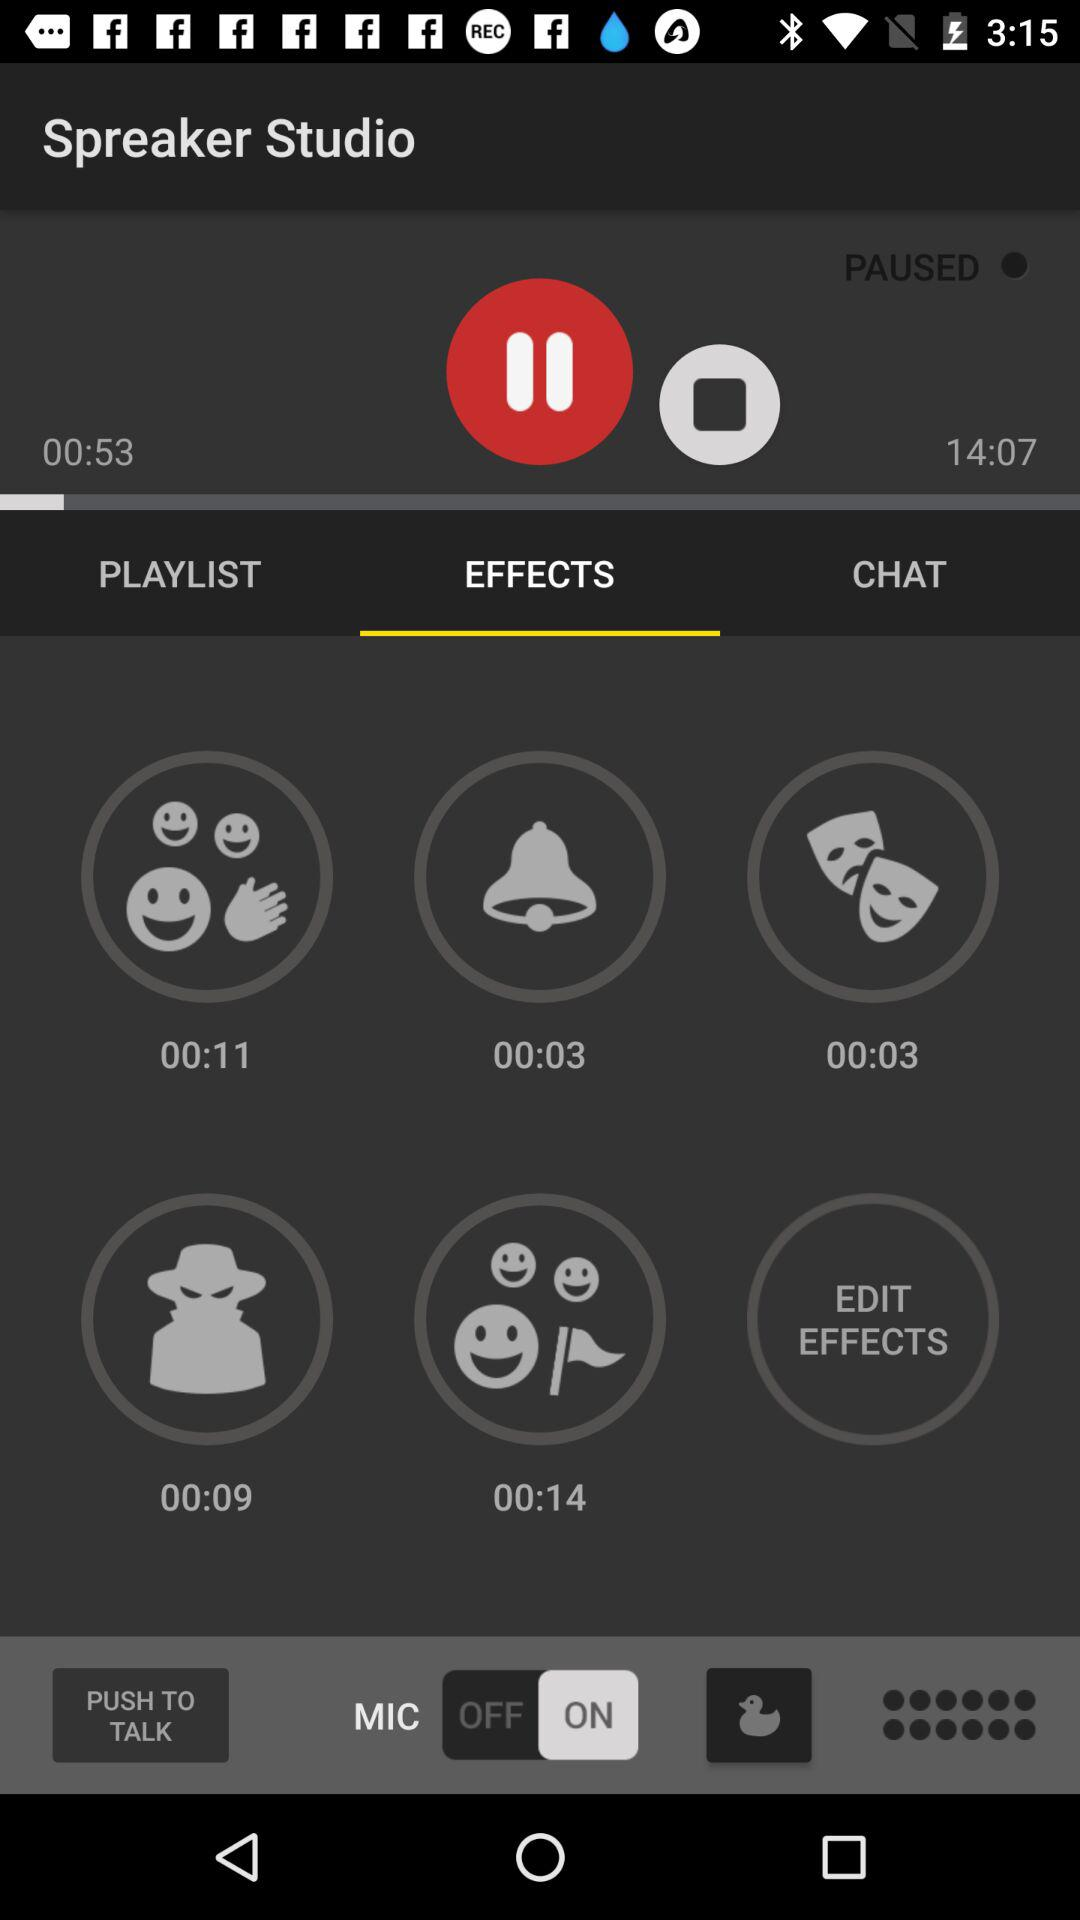What is the total time of the audio that is played? The total time is 14 minutes and 7 seconds. 